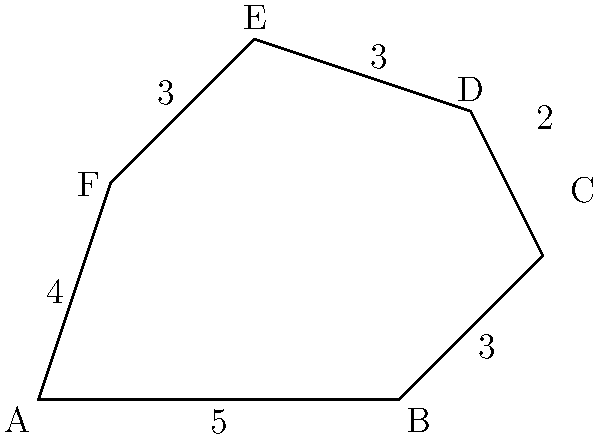As the constituent services director, you're tasked with calculating the perimeter of an irregularly shaped community district for a grassroots campaign. The district is represented by the polygon ABCDEF shown above, where the length of each side is given in miles. What is the total perimeter of this community district? To calculate the perimeter of the irregular polygon ABCDEF, we need to sum the lengths of all its sides. Let's go through this step-by-step:

1. Side AB: 5 miles
2. Side BC: 3 miles
3. Side CD: 2 miles
4. Side DE: 3 miles
5. Side EF: 3 miles
6. Side FA: 4 miles

Now, let's add all these lengths together:

$$\text{Perimeter} = AB + BC + CD + DE + EF + FA$$
$$\text{Perimeter} = 5 + 3 + 2 + 3 + 3 + 4$$
$$\text{Perimeter} = 20 \text{ miles}$$

Therefore, the total perimeter of the community district is 20 miles.
Answer: 20 miles 